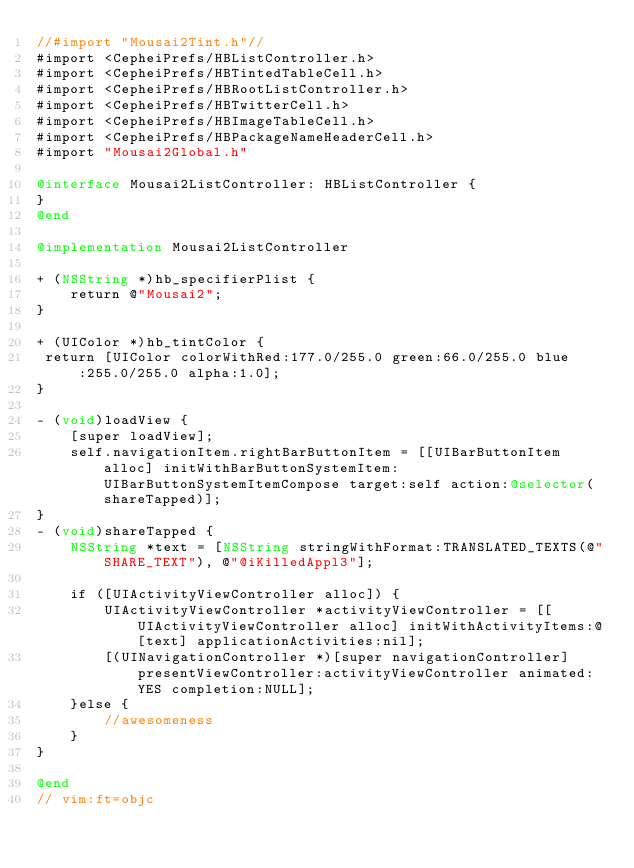<code> <loc_0><loc_0><loc_500><loc_500><_ObjectiveC_>//#import "Mousai2Tint.h"//
#import <CepheiPrefs/HBListController.h>
#import <CepheiPrefs/HBTintedTableCell.h>
#import <CepheiPrefs/HBRootListController.h>
#import <CepheiPrefs/HBTwitterCell.h>
#import <CepheiPrefs/HBImageTableCell.h>
#import <CepheiPrefs/HBPackageNameHeaderCell.h>
#import "Mousai2Global.h"

@interface Mousai2ListController: HBListController {
}
@end

@implementation Mousai2ListController

+ (NSString *)hb_specifierPlist {
	return @"Mousai2";
}

+ (UIColor *)hb_tintColor {
 return [UIColor colorWithRed:177.0/255.0 green:66.0/255.0 blue:255.0/255.0 alpha:1.0];
}

- (void)loadView {
    [super loadView];
    self.navigationItem.rightBarButtonItem = [[UIBarButtonItem alloc] initWithBarButtonSystemItem:UIBarButtonSystemItemCompose target:self action:@selector(shareTapped)];
}
- (void)shareTapped {
	NSString *text = [NSString stringWithFormat:TRANSLATED_TEXTS(@"SHARE_TEXT"), @"@iKilledAppl3"];

	if ([UIActivityViewController alloc]) {
		UIActivityViewController *activityViewController = [[UIActivityViewController alloc] initWithActivityItems:@[text] applicationActivities:nil];
		[(UINavigationController *)[super navigationController] presentViewController:activityViewController animated:YES completion:NULL];
	}else {
		//awesomeness
	}
}

@end
// vim:ft=objc
</code> 